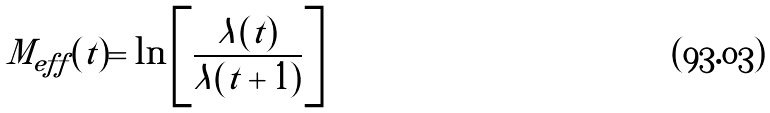<formula> <loc_0><loc_0><loc_500><loc_500>M _ { e f f } ( t ) = \ln \left [ \frac { \lambda ( t ) } { \lambda ( t + 1 ) } \right ]</formula> 